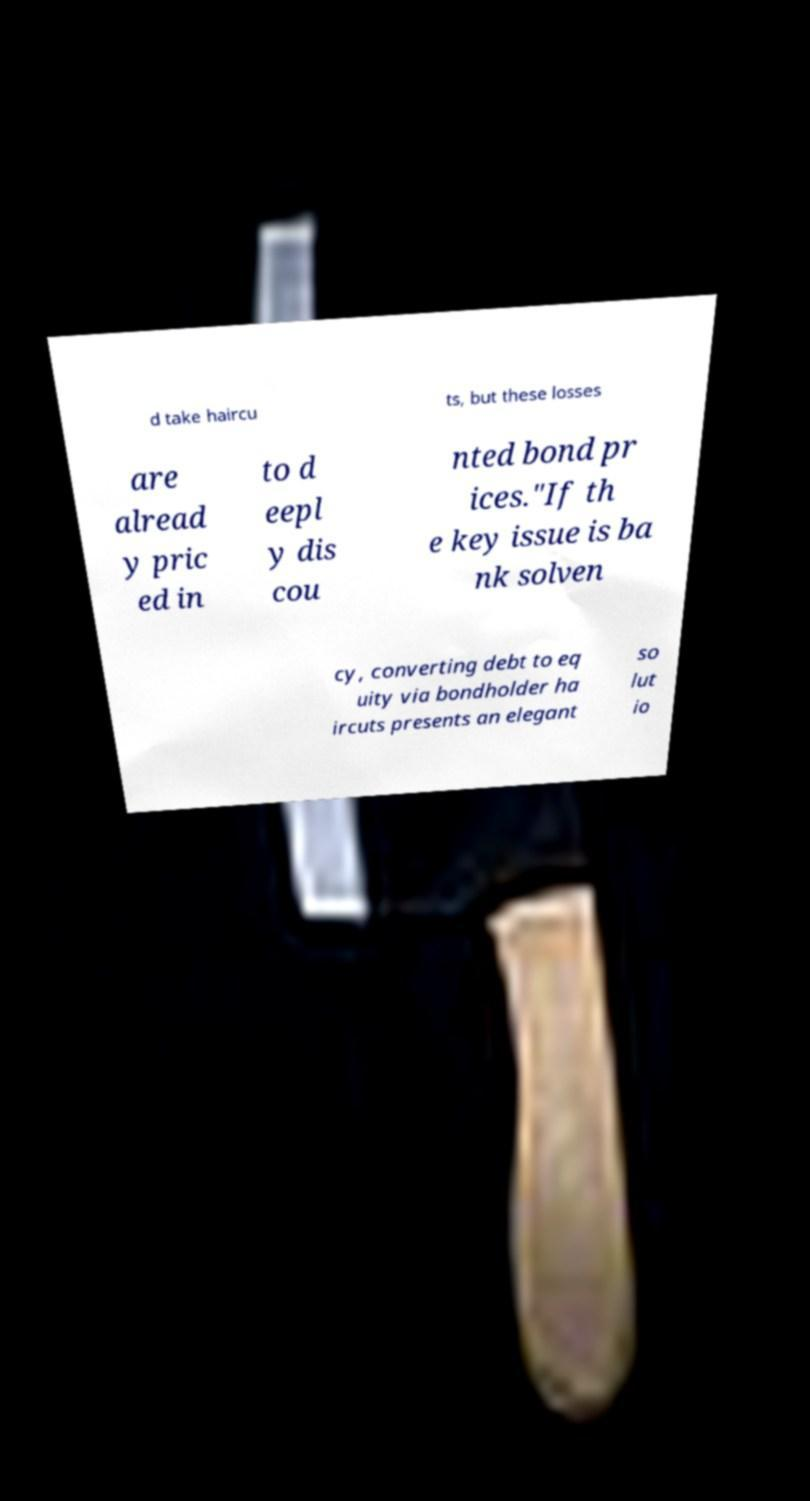Can you read and provide the text displayed in the image?This photo seems to have some interesting text. Can you extract and type it out for me? d take haircu ts, but these losses are alread y pric ed in to d eepl y dis cou nted bond pr ices."If th e key issue is ba nk solven cy, converting debt to eq uity via bondholder ha ircuts presents an elegant so lut io 